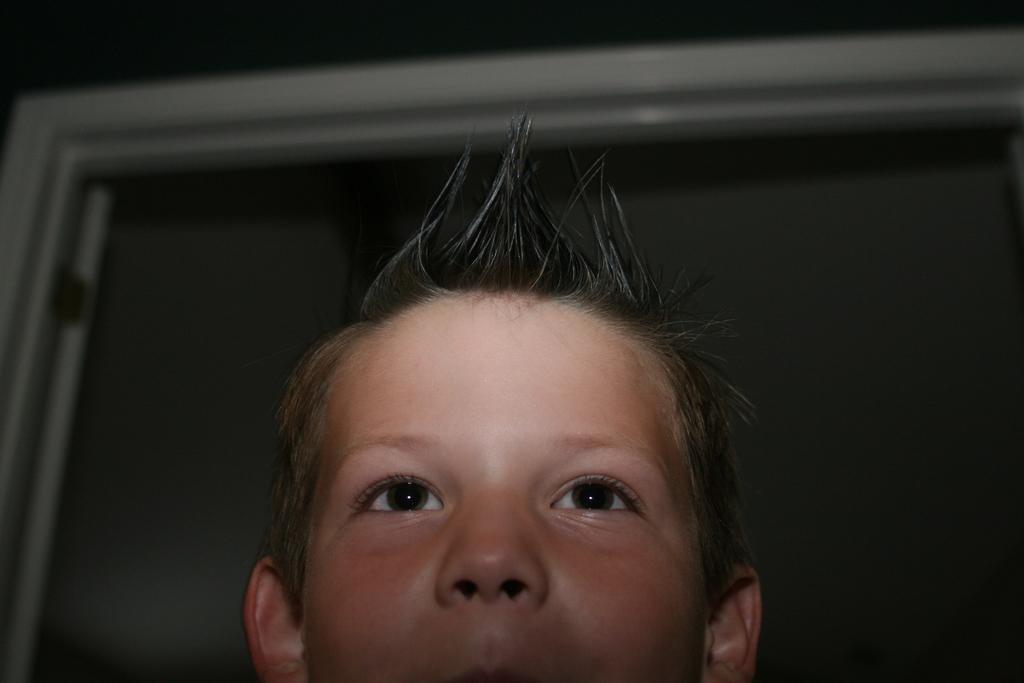Could you give a brief overview of what you see in this image? In this image we can see a boy. In the background there is a door. 